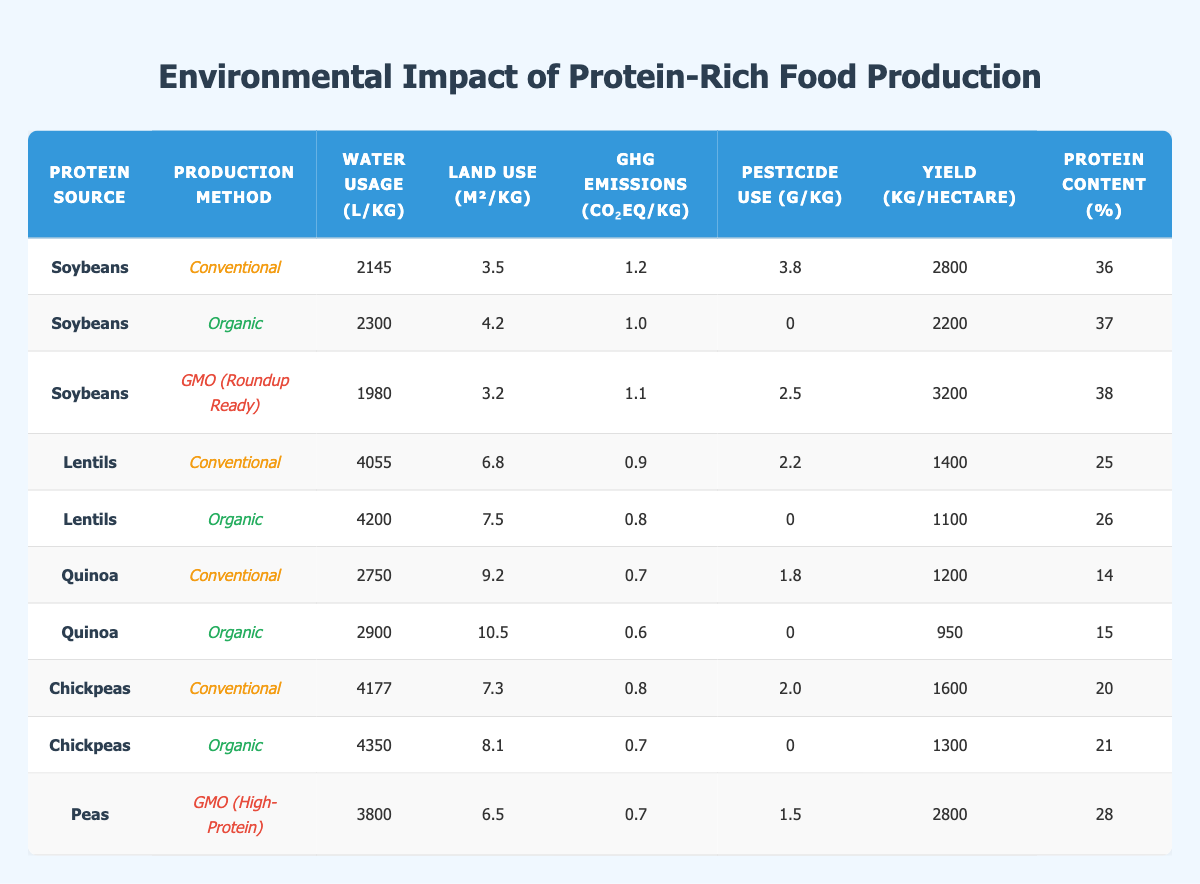What is the water usage for organic soybeans? In the table, I can see that organic soybeans have a water usage of 2300 L/kg listed in the corresponding row.
Answer: 2300 L/kg Which production method for lentils has the lowest greenhouse gas emissions? Comparing the GHG emissions for conventional lentils (0.9 CO₂eq/kg) and organic lentils (0.8 CO₂eq/kg), organic lentils have lower emissions.
Answer: Organic What is the total land use in square meters for GMO (Roundup Ready) soybeans and organic lentils combined? The land use for GMO soybeans is 3.2 m²/kg and for organic lentils is 7.5 m²/kg. Adding them gives 3.2 + 7.5 = 10.7 m²/kg.
Answer: 10.7 m²/kg Do organic chickpeas use more pesticides than conventional chickpeas? From the table, conventional chickpeas use 2.0 g/kg of pesticides while organic chickpeas use 0 g/kg. Therefore, organic chickpeas use less pesticides.
Answer: No Which protein source has the highest yield per hectare in the conventional method? Looking at the yields per hectare in the conventional method, soybeans yield 2800 kg/hectare, lentils yield 1400 kg/hectare, quinoa yields 1200 kg/hectare, and chickpeas yield 1600 kg/hectare. Soybeans have the highest yield.
Answer: Soybeans What is the average protein content of organic plant-based protein sources listed? The protein content for organic soybeans is 37%, organic lentils is 26%, organic quinoa is 15%, and organic chickpeas is 21%. The average is (37 + 26 + 15 + 21) / 4 = 24.75%.
Answer: 24.75% Is the yield for GMO (High-Protein) peas higher than that of conventional lentils? The yield for GMO (High-Protein) peas is 2800 kg/hectare, while conventional lentils yield only 1400 kg/hectare. Therefore, GMO peas have a higher yield.
Answer: Yes Which production method produces protein sources with the lowest pesticide usage overall? From the table, both organic soybeans and organic lentils have a pesticide usage of 0 g/kg. Thus, the organic method yields the lowest pesticide usage overall.
Answer: Organic What is the difference in GHG emissions between GMO soybeans and conventional chickpeas? GMO soybeans have GHG emissions of 1.1 CO₂eq/kg, while conventional chickpeas have 0.8 CO₂eq/kg. The difference is 1.1 - 0.8 = 0.3 CO₂eq/kg.
Answer: 0.3 CO₂eq/kg 